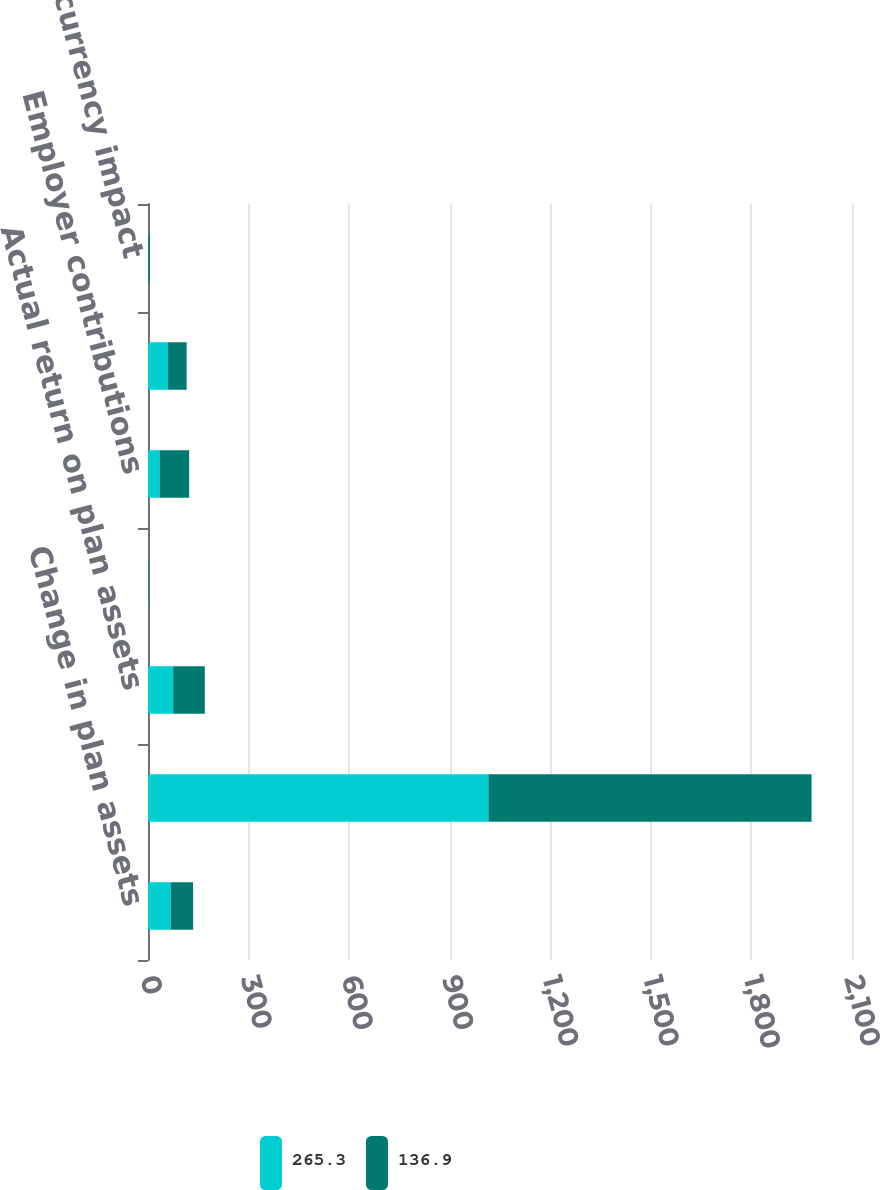Convert chart. <chart><loc_0><loc_0><loc_500><loc_500><stacked_bar_chart><ecel><fcel>Change in plan assets<fcel>Fair value of plan assets at<fcel>Actual return on plan assets<fcel>Plan participants'<fcel>Employer contributions<fcel>Benefits paid<fcel>Foreign currency impact<nl><fcel>265.3<fcel>67.3<fcel>1015.4<fcel>75.1<fcel>1.2<fcel>35.3<fcel>59.5<fcel>0.7<nl><fcel>136.9<fcel>67.3<fcel>964<fcel>94.3<fcel>1.3<fcel>87.5<fcel>55.8<fcel>4.2<nl></chart> 